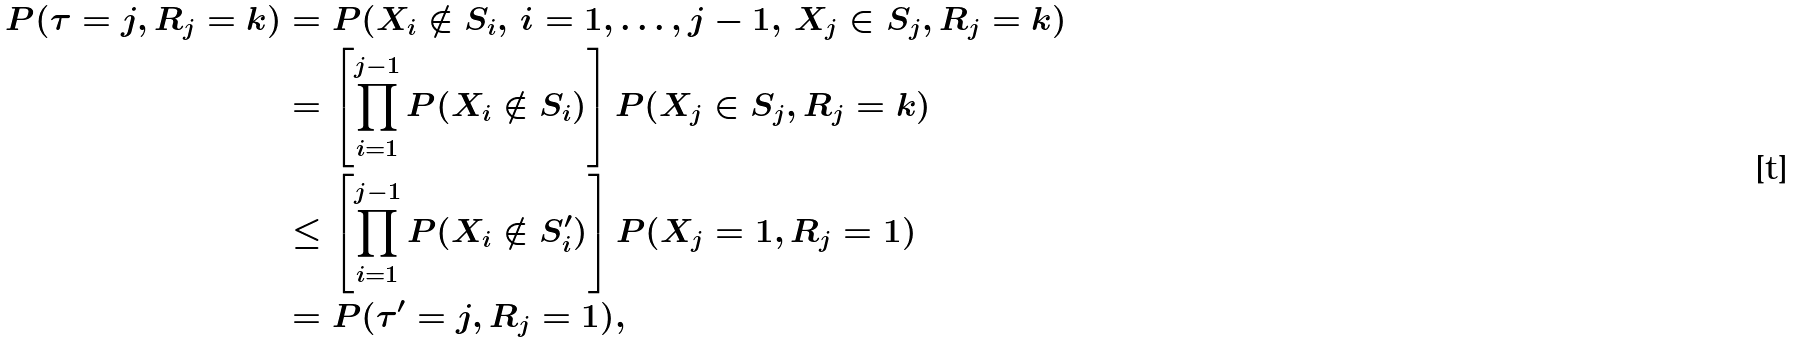<formula> <loc_0><loc_0><loc_500><loc_500>P ( \tau = j , R _ { j } = k ) & = P ( X _ { i } \notin S _ { i } , \, i = 1 , \dots , j - 1 , \, X _ { j } \in S _ { j } , R _ { j } = k ) \\ & = \left [ \prod _ { i = 1 } ^ { j - 1 } P ( X _ { i } \notin S _ { i } ) \right ] P ( X _ { j } \in S _ { j } , R _ { j } = k ) \\ & \leq \left [ \prod _ { i = 1 } ^ { j - 1 } P ( X _ { i } \notin S _ { i } ^ { \prime } ) \right ] P ( X _ { j } = 1 , R _ { j } = 1 ) \\ & = P ( \tau ^ { \prime } = j , R _ { j } = 1 ) ,</formula> 